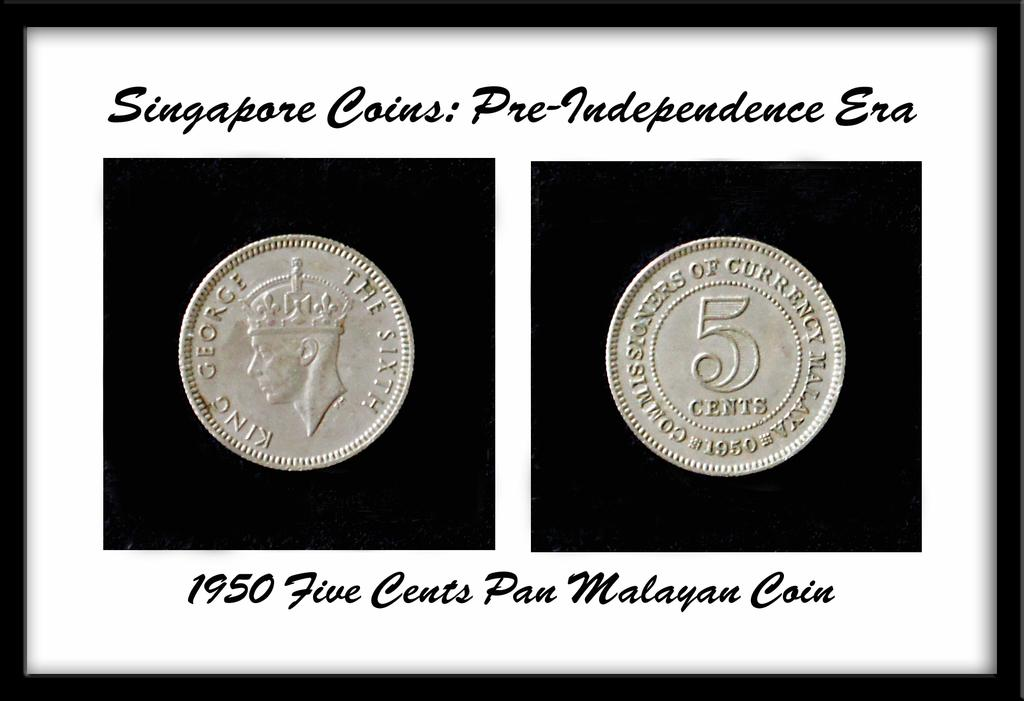<image>
Describe the image concisely. Framed coins are labeled with the year 1950 below. 